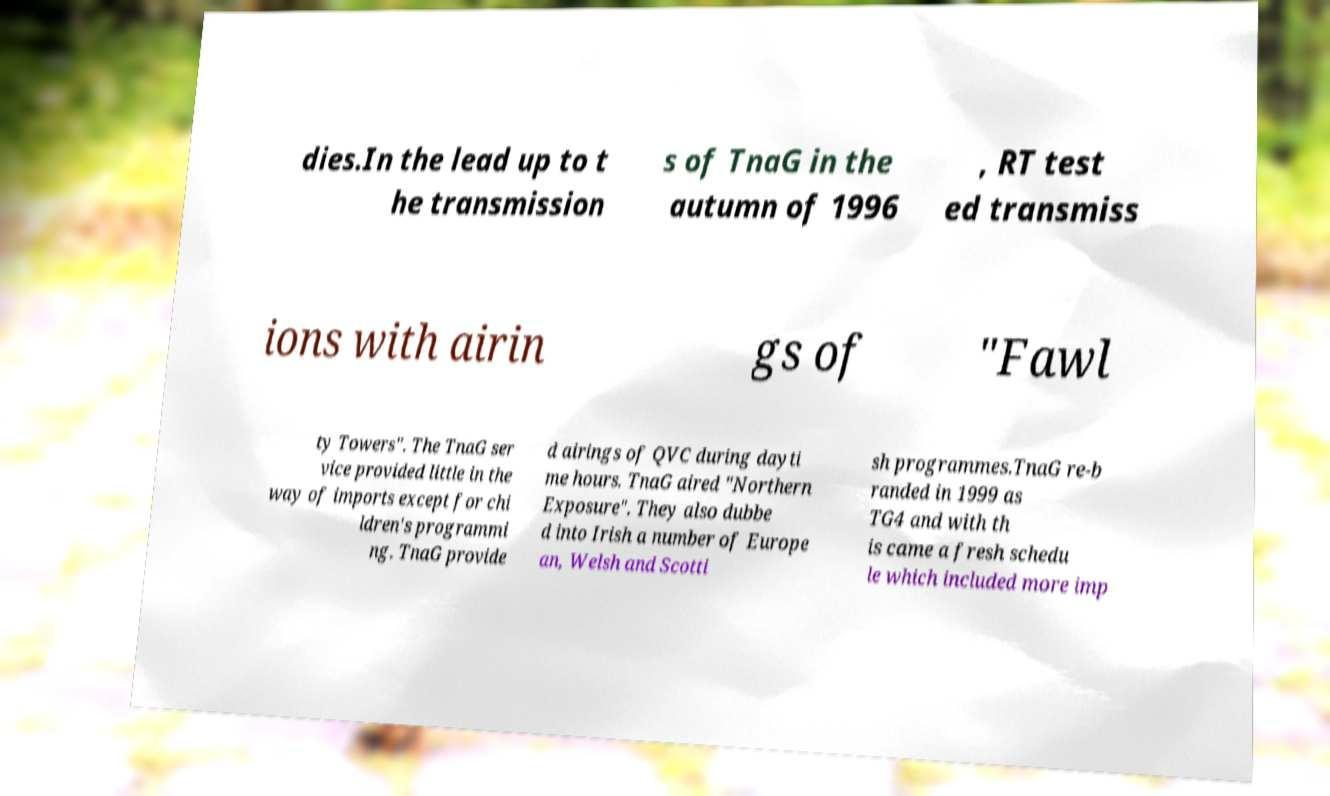Please identify and transcribe the text found in this image. dies.In the lead up to t he transmission s of TnaG in the autumn of 1996 , RT test ed transmiss ions with airin gs of "Fawl ty Towers". The TnaG ser vice provided little in the way of imports except for chi ldren's programmi ng. TnaG provide d airings of QVC during dayti me hours. TnaG aired "Northern Exposure". They also dubbe d into Irish a number of Europe an, Welsh and Scotti sh programmes.TnaG re-b randed in 1999 as TG4 and with th is came a fresh schedu le which included more imp 